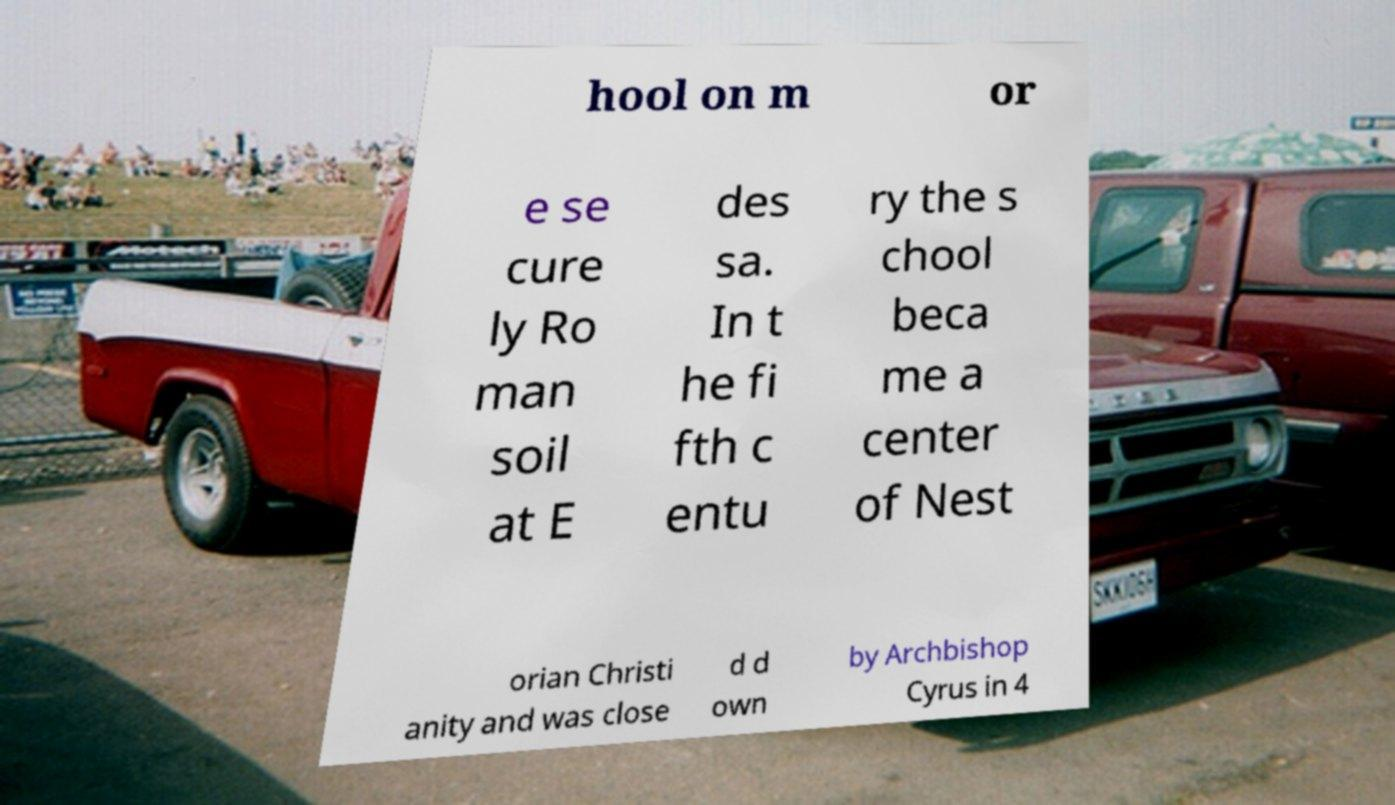Please identify and transcribe the text found in this image. hool on m or e se cure ly Ro man soil at E des sa. In t he fi fth c entu ry the s chool beca me a center of Nest orian Christi anity and was close d d own by Archbishop Cyrus in 4 